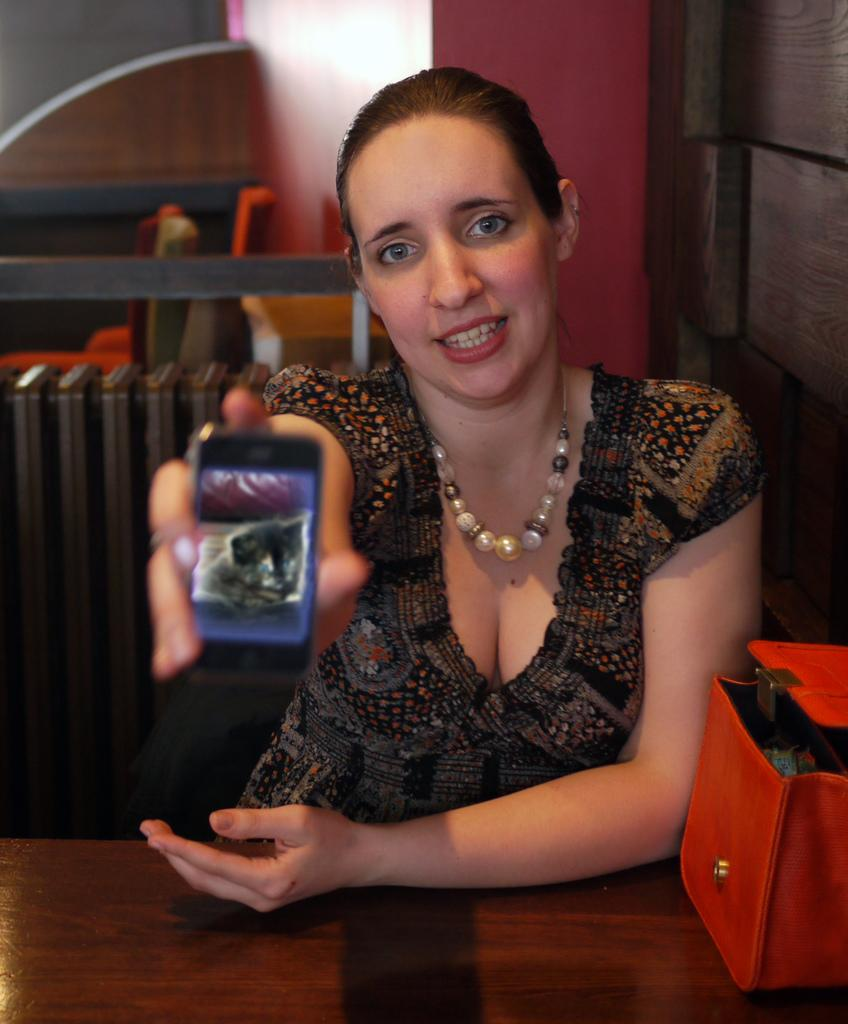Who is the main subject in the image? There is a lady in the image. What is the lady doing in the image? The lady is sitting on a table. What object is the lady holding in her hand? The lady is holding a mobile phone in her hand. What accessory is the lady wearing in the image? The lady is wearing a necklace. What item is beside the lady on the table? The lady has a handbag beside her. What type of brass instrument is the lady playing in the image? There is no brass instrument present in the image; the lady is holding a mobile phone. What kind of sheet is covering the table in the image? There is no sheet covering the table in the image; the lady is sitting directly on the table. 